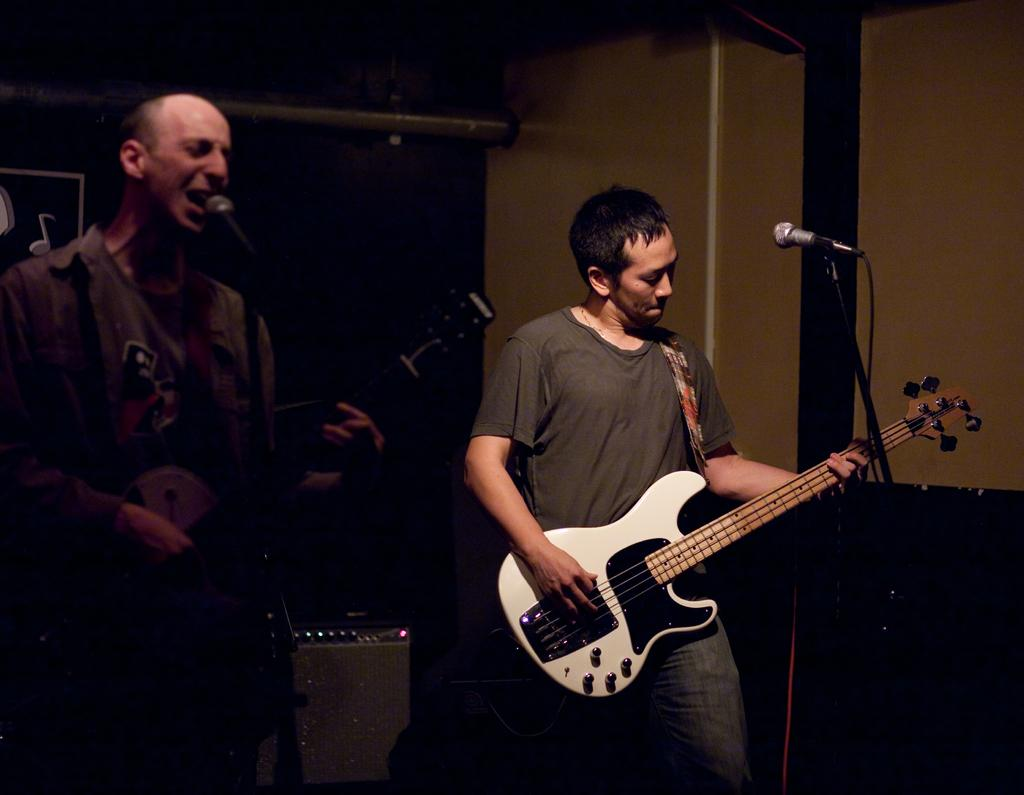What is the person on the right side of the image doing? The person on the right side is playing a guitar. What is the person on the left side of the image doing? The person on the left side is singing on a microphone. How many people are visible in the image? There are two people visible in the image. What type of root can be seen growing near the person on the left side of the image? There is no root visible in the image; it features two people, one playing a guitar and the other singing on a microphone. 